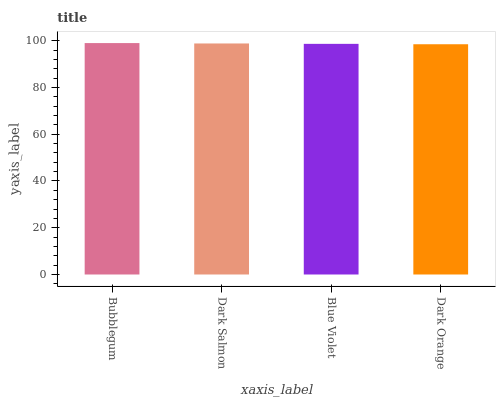Is Dark Orange the minimum?
Answer yes or no. Yes. Is Bubblegum the maximum?
Answer yes or no. Yes. Is Dark Salmon the minimum?
Answer yes or no. No. Is Dark Salmon the maximum?
Answer yes or no. No. Is Bubblegum greater than Dark Salmon?
Answer yes or no. Yes. Is Dark Salmon less than Bubblegum?
Answer yes or no. Yes. Is Dark Salmon greater than Bubblegum?
Answer yes or no. No. Is Bubblegum less than Dark Salmon?
Answer yes or no. No. Is Dark Salmon the high median?
Answer yes or no. Yes. Is Blue Violet the low median?
Answer yes or no. Yes. Is Blue Violet the high median?
Answer yes or no. No. Is Bubblegum the low median?
Answer yes or no. No. 